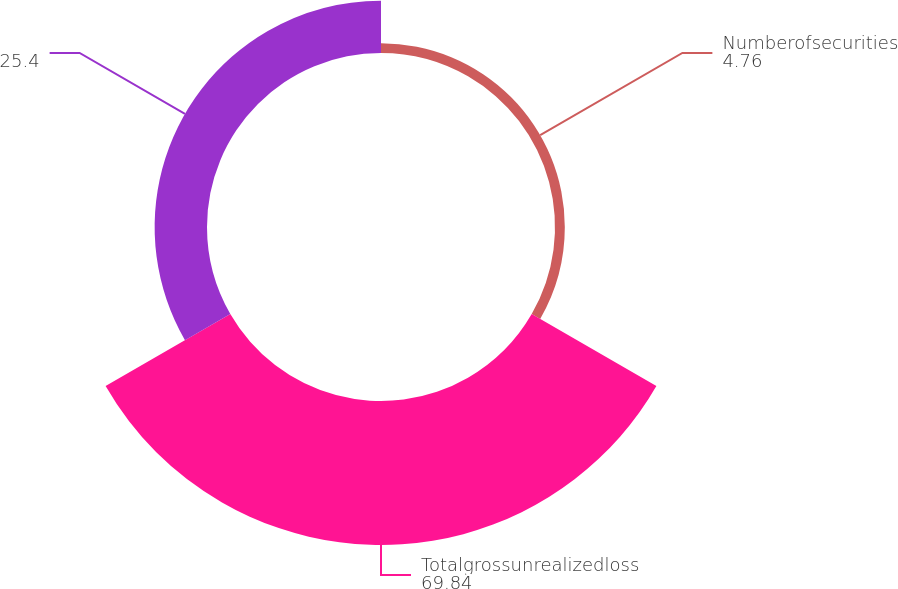<chart> <loc_0><loc_0><loc_500><loc_500><pie_chart><fcel>Numberofsecurities<fcel>Totalgrossunrealizedloss<fcel>Unnamed: 2<nl><fcel>4.76%<fcel>69.84%<fcel>25.4%<nl></chart> 